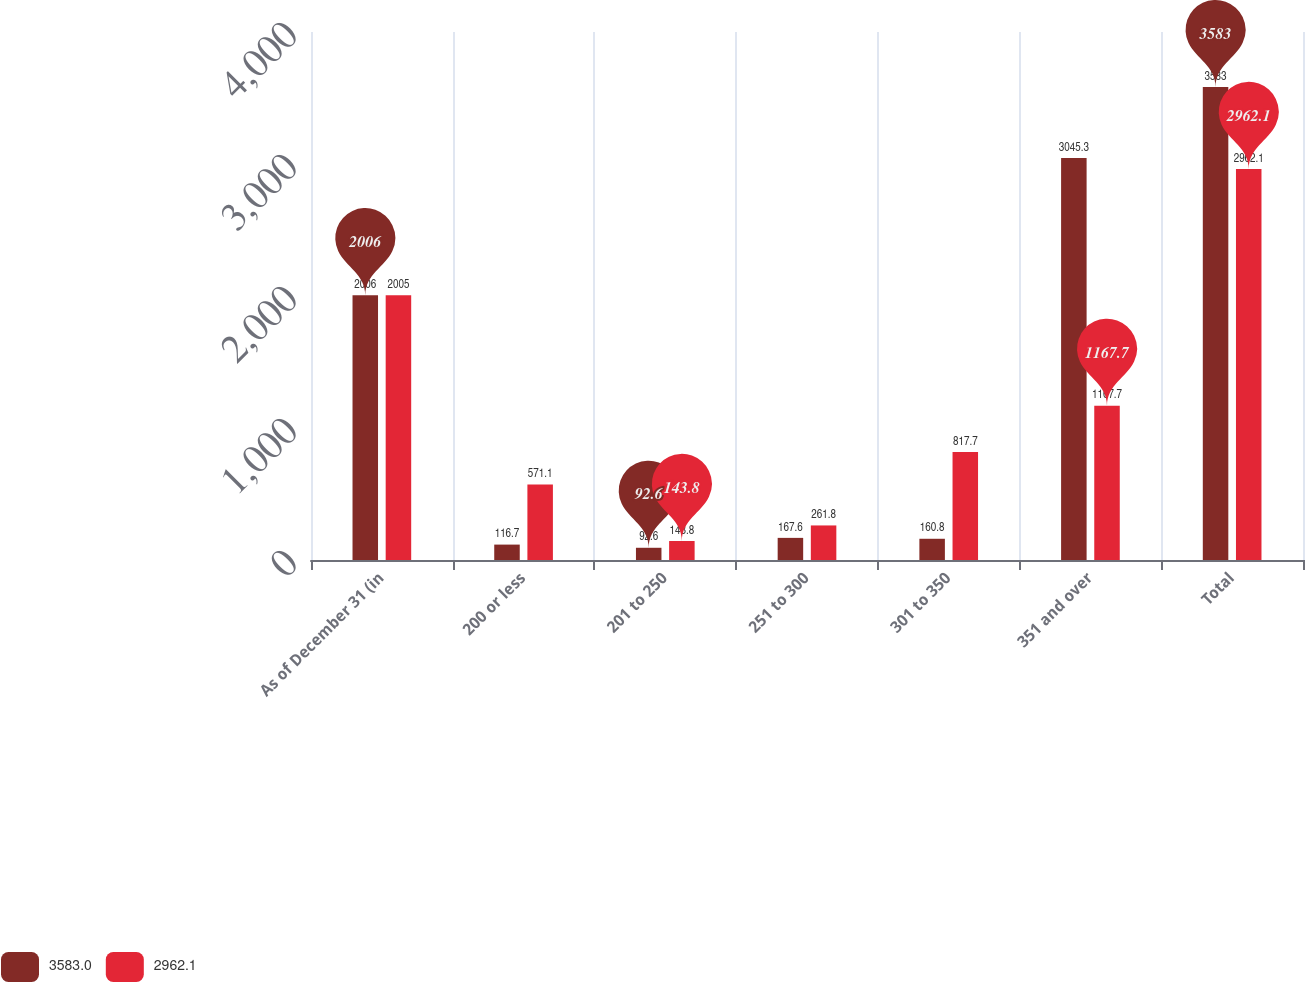Convert chart. <chart><loc_0><loc_0><loc_500><loc_500><stacked_bar_chart><ecel><fcel>As of December 31 (in<fcel>200 or less<fcel>201 to 250<fcel>251 to 300<fcel>301 to 350<fcel>351 and over<fcel>Total<nl><fcel>3583<fcel>2006<fcel>116.7<fcel>92.6<fcel>167.6<fcel>160.8<fcel>3045.3<fcel>3583<nl><fcel>2962.1<fcel>2005<fcel>571.1<fcel>143.8<fcel>261.8<fcel>817.7<fcel>1167.7<fcel>2962.1<nl></chart> 